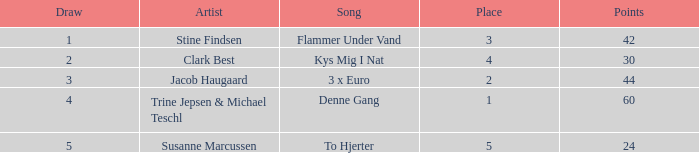What draw has over 44 points and holds a place higher than 1? None. 